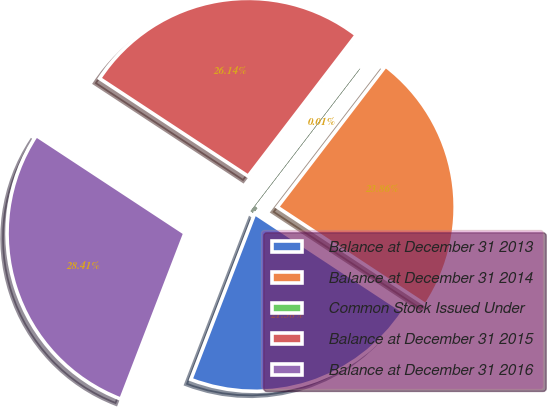Convert chart. <chart><loc_0><loc_0><loc_500><loc_500><pie_chart><fcel>Balance at December 31 2013<fcel>Balance at December 31 2014<fcel>Common Stock Issued Under<fcel>Balance at December 31 2015<fcel>Balance at December 31 2016<nl><fcel>21.58%<fcel>23.86%<fcel>0.01%<fcel>26.14%<fcel>28.41%<nl></chart> 